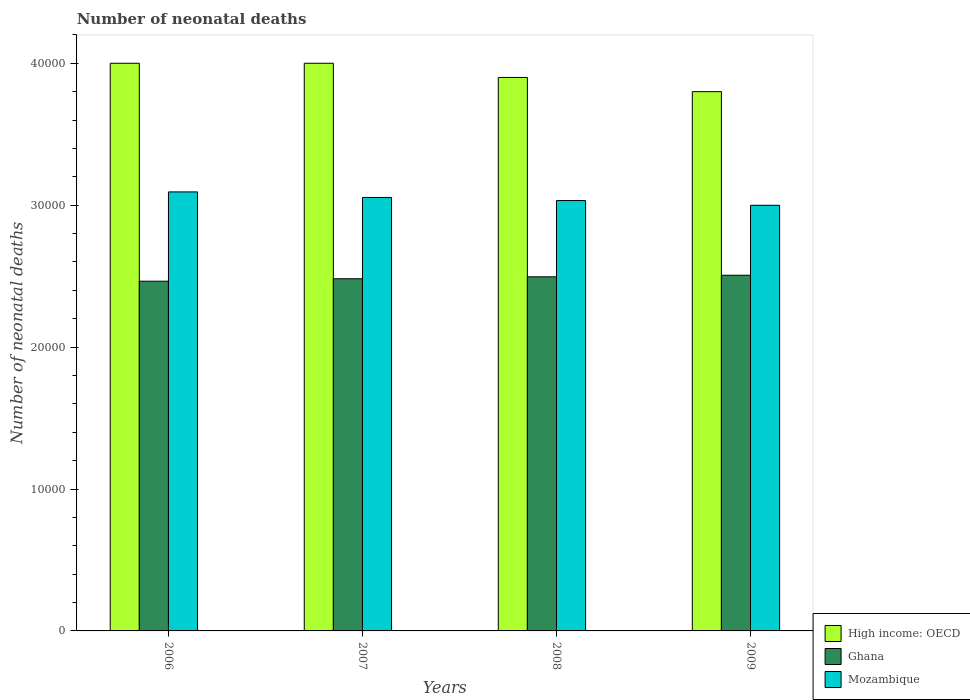How many groups of bars are there?
Provide a short and direct response. 4. Are the number of bars per tick equal to the number of legend labels?
Offer a terse response. Yes. How many bars are there on the 1st tick from the left?
Provide a short and direct response. 3. What is the label of the 2nd group of bars from the left?
Provide a succinct answer. 2007. In how many cases, is the number of bars for a given year not equal to the number of legend labels?
Make the answer very short. 0. What is the number of neonatal deaths in in Ghana in 2009?
Provide a succinct answer. 2.51e+04. Across all years, what is the maximum number of neonatal deaths in in Ghana?
Your answer should be very brief. 2.51e+04. Across all years, what is the minimum number of neonatal deaths in in High income: OECD?
Keep it short and to the point. 3.80e+04. In which year was the number of neonatal deaths in in Ghana maximum?
Keep it short and to the point. 2009. What is the total number of neonatal deaths in in High income: OECD in the graph?
Give a very brief answer. 1.57e+05. What is the difference between the number of neonatal deaths in in High income: OECD in 2007 and that in 2008?
Keep it short and to the point. 1000. What is the difference between the number of neonatal deaths in in High income: OECD in 2007 and the number of neonatal deaths in in Ghana in 2009?
Give a very brief answer. 1.49e+04. What is the average number of neonatal deaths in in Ghana per year?
Ensure brevity in your answer.  2.49e+04. In the year 2006, what is the difference between the number of neonatal deaths in in Ghana and number of neonatal deaths in in Mozambique?
Give a very brief answer. -6292. What is the ratio of the number of neonatal deaths in in High income: OECD in 2007 to that in 2009?
Keep it short and to the point. 1.05. Is the number of neonatal deaths in in High income: OECD in 2007 less than that in 2008?
Provide a succinct answer. No. What is the difference between the highest and the second highest number of neonatal deaths in in Mozambique?
Make the answer very short. 390. What is the difference between the highest and the lowest number of neonatal deaths in in High income: OECD?
Make the answer very short. 2000. What does the 2nd bar from the left in 2007 represents?
Offer a terse response. Ghana. What does the 3rd bar from the right in 2008 represents?
Provide a short and direct response. High income: OECD. Is it the case that in every year, the sum of the number of neonatal deaths in in Mozambique and number of neonatal deaths in in Ghana is greater than the number of neonatal deaths in in High income: OECD?
Provide a short and direct response. Yes. Are all the bars in the graph horizontal?
Your answer should be very brief. No. How many years are there in the graph?
Make the answer very short. 4. What is the difference between two consecutive major ticks on the Y-axis?
Offer a terse response. 10000. Does the graph contain any zero values?
Make the answer very short. No. How many legend labels are there?
Your answer should be very brief. 3. How are the legend labels stacked?
Give a very brief answer. Vertical. What is the title of the graph?
Offer a very short reply. Number of neonatal deaths. Does "Jamaica" appear as one of the legend labels in the graph?
Your response must be concise. No. What is the label or title of the X-axis?
Provide a short and direct response. Years. What is the label or title of the Y-axis?
Ensure brevity in your answer.  Number of neonatal deaths. What is the Number of neonatal deaths of Ghana in 2006?
Ensure brevity in your answer.  2.46e+04. What is the Number of neonatal deaths of Mozambique in 2006?
Provide a short and direct response. 3.09e+04. What is the Number of neonatal deaths of High income: OECD in 2007?
Offer a very short reply. 4.00e+04. What is the Number of neonatal deaths of Ghana in 2007?
Make the answer very short. 2.48e+04. What is the Number of neonatal deaths of Mozambique in 2007?
Your response must be concise. 3.05e+04. What is the Number of neonatal deaths in High income: OECD in 2008?
Your answer should be very brief. 3.90e+04. What is the Number of neonatal deaths of Ghana in 2008?
Your answer should be compact. 2.50e+04. What is the Number of neonatal deaths in Mozambique in 2008?
Provide a short and direct response. 3.03e+04. What is the Number of neonatal deaths of High income: OECD in 2009?
Give a very brief answer. 3.80e+04. What is the Number of neonatal deaths of Ghana in 2009?
Your response must be concise. 2.51e+04. What is the Number of neonatal deaths of Mozambique in 2009?
Keep it short and to the point. 3.00e+04. Across all years, what is the maximum Number of neonatal deaths in High income: OECD?
Keep it short and to the point. 4.00e+04. Across all years, what is the maximum Number of neonatal deaths in Ghana?
Make the answer very short. 2.51e+04. Across all years, what is the maximum Number of neonatal deaths of Mozambique?
Your response must be concise. 3.09e+04. Across all years, what is the minimum Number of neonatal deaths in High income: OECD?
Your response must be concise. 3.80e+04. Across all years, what is the minimum Number of neonatal deaths of Ghana?
Ensure brevity in your answer.  2.46e+04. Across all years, what is the minimum Number of neonatal deaths in Mozambique?
Make the answer very short. 3.00e+04. What is the total Number of neonatal deaths of High income: OECD in the graph?
Make the answer very short. 1.57e+05. What is the total Number of neonatal deaths of Ghana in the graph?
Your response must be concise. 9.95e+04. What is the total Number of neonatal deaths in Mozambique in the graph?
Make the answer very short. 1.22e+05. What is the difference between the Number of neonatal deaths in High income: OECD in 2006 and that in 2007?
Provide a short and direct response. 0. What is the difference between the Number of neonatal deaths in Ghana in 2006 and that in 2007?
Your answer should be very brief. -173. What is the difference between the Number of neonatal deaths of Mozambique in 2006 and that in 2007?
Your response must be concise. 390. What is the difference between the Number of neonatal deaths of Ghana in 2006 and that in 2008?
Make the answer very short. -308. What is the difference between the Number of neonatal deaths of Mozambique in 2006 and that in 2008?
Provide a succinct answer. 608. What is the difference between the Number of neonatal deaths in Ghana in 2006 and that in 2009?
Offer a very short reply. -421. What is the difference between the Number of neonatal deaths in Mozambique in 2006 and that in 2009?
Offer a terse response. 943. What is the difference between the Number of neonatal deaths in High income: OECD in 2007 and that in 2008?
Provide a short and direct response. 1000. What is the difference between the Number of neonatal deaths in Ghana in 2007 and that in 2008?
Keep it short and to the point. -135. What is the difference between the Number of neonatal deaths of Mozambique in 2007 and that in 2008?
Provide a short and direct response. 218. What is the difference between the Number of neonatal deaths in High income: OECD in 2007 and that in 2009?
Your answer should be compact. 2000. What is the difference between the Number of neonatal deaths in Ghana in 2007 and that in 2009?
Make the answer very short. -248. What is the difference between the Number of neonatal deaths in Mozambique in 2007 and that in 2009?
Provide a succinct answer. 553. What is the difference between the Number of neonatal deaths of Ghana in 2008 and that in 2009?
Your answer should be very brief. -113. What is the difference between the Number of neonatal deaths in Mozambique in 2008 and that in 2009?
Provide a succinct answer. 335. What is the difference between the Number of neonatal deaths in High income: OECD in 2006 and the Number of neonatal deaths in Ghana in 2007?
Provide a succinct answer. 1.52e+04. What is the difference between the Number of neonatal deaths in High income: OECD in 2006 and the Number of neonatal deaths in Mozambique in 2007?
Keep it short and to the point. 9456. What is the difference between the Number of neonatal deaths of Ghana in 2006 and the Number of neonatal deaths of Mozambique in 2007?
Offer a terse response. -5902. What is the difference between the Number of neonatal deaths of High income: OECD in 2006 and the Number of neonatal deaths of Ghana in 2008?
Keep it short and to the point. 1.50e+04. What is the difference between the Number of neonatal deaths in High income: OECD in 2006 and the Number of neonatal deaths in Mozambique in 2008?
Your answer should be compact. 9674. What is the difference between the Number of neonatal deaths of Ghana in 2006 and the Number of neonatal deaths of Mozambique in 2008?
Ensure brevity in your answer.  -5684. What is the difference between the Number of neonatal deaths of High income: OECD in 2006 and the Number of neonatal deaths of Ghana in 2009?
Your response must be concise. 1.49e+04. What is the difference between the Number of neonatal deaths in High income: OECD in 2006 and the Number of neonatal deaths in Mozambique in 2009?
Offer a very short reply. 1.00e+04. What is the difference between the Number of neonatal deaths of Ghana in 2006 and the Number of neonatal deaths of Mozambique in 2009?
Make the answer very short. -5349. What is the difference between the Number of neonatal deaths in High income: OECD in 2007 and the Number of neonatal deaths in Ghana in 2008?
Provide a succinct answer. 1.50e+04. What is the difference between the Number of neonatal deaths of High income: OECD in 2007 and the Number of neonatal deaths of Mozambique in 2008?
Your response must be concise. 9674. What is the difference between the Number of neonatal deaths in Ghana in 2007 and the Number of neonatal deaths in Mozambique in 2008?
Provide a succinct answer. -5511. What is the difference between the Number of neonatal deaths of High income: OECD in 2007 and the Number of neonatal deaths of Ghana in 2009?
Ensure brevity in your answer.  1.49e+04. What is the difference between the Number of neonatal deaths in High income: OECD in 2007 and the Number of neonatal deaths in Mozambique in 2009?
Offer a terse response. 1.00e+04. What is the difference between the Number of neonatal deaths in Ghana in 2007 and the Number of neonatal deaths in Mozambique in 2009?
Your answer should be very brief. -5176. What is the difference between the Number of neonatal deaths in High income: OECD in 2008 and the Number of neonatal deaths in Ghana in 2009?
Your answer should be compact. 1.39e+04. What is the difference between the Number of neonatal deaths in High income: OECD in 2008 and the Number of neonatal deaths in Mozambique in 2009?
Ensure brevity in your answer.  9009. What is the difference between the Number of neonatal deaths in Ghana in 2008 and the Number of neonatal deaths in Mozambique in 2009?
Ensure brevity in your answer.  -5041. What is the average Number of neonatal deaths of High income: OECD per year?
Your answer should be compact. 3.92e+04. What is the average Number of neonatal deaths in Ghana per year?
Provide a short and direct response. 2.49e+04. What is the average Number of neonatal deaths in Mozambique per year?
Keep it short and to the point. 3.04e+04. In the year 2006, what is the difference between the Number of neonatal deaths in High income: OECD and Number of neonatal deaths in Ghana?
Make the answer very short. 1.54e+04. In the year 2006, what is the difference between the Number of neonatal deaths of High income: OECD and Number of neonatal deaths of Mozambique?
Offer a very short reply. 9066. In the year 2006, what is the difference between the Number of neonatal deaths in Ghana and Number of neonatal deaths in Mozambique?
Make the answer very short. -6292. In the year 2007, what is the difference between the Number of neonatal deaths of High income: OECD and Number of neonatal deaths of Ghana?
Provide a succinct answer. 1.52e+04. In the year 2007, what is the difference between the Number of neonatal deaths in High income: OECD and Number of neonatal deaths in Mozambique?
Keep it short and to the point. 9456. In the year 2007, what is the difference between the Number of neonatal deaths of Ghana and Number of neonatal deaths of Mozambique?
Keep it short and to the point. -5729. In the year 2008, what is the difference between the Number of neonatal deaths in High income: OECD and Number of neonatal deaths in Ghana?
Ensure brevity in your answer.  1.40e+04. In the year 2008, what is the difference between the Number of neonatal deaths of High income: OECD and Number of neonatal deaths of Mozambique?
Provide a short and direct response. 8674. In the year 2008, what is the difference between the Number of neonatal deaths in Ghana and Number of neonatal deaths in Mozambique?
Your answer should be compact. -5376. In the year 2009, what is the difference between the Number of neonatal deaths of High income: OECD and Number of neonatal deaths of Ghana?
Ensure brevity in your answer.  1.29e+04. In the year 2009, what is the difference between the Number of neonatal deaths of High income: OECD and Number of neonatal deaths of Mozambique?
Offer a very short reply. 8009. In the year 2009, what is the difference between the Number of neonatal deaths in Ghana and Number of neonatal deaths in Mozambique?
Make the answer very short. -4928. What is the ratio of the Number of neonatal deaths of High income: OECD in 2006 to that in 2007?
Your answer should be compact. 1. What is the ratio of the Number of neonatal deaths of Mozambique in 2006 to that in 2007?
Your answer should be very brief. 1.01. What is the ratio of the Number of neonatal deaths in High income: OECD in 2006 to that in 2008?
Ensure brevity in your answer.  1.03. What is the ratio of the Number of neonatal deaths in Ghana in 2006 to that in 2008?
Your answer should be compact. 0.99. What is the ratio of the Number of neonatal deaths of High income: OECD in 2006 to that in 2009?
Offer a terse response. 1.05. What is the ratio of the Number of neonatal deaths in Ghana in 2006 to that in 2009?
Make the answer very short. 0.98. What is the ratio of the Number of neonatal deaths in Mozambique in 2006 to that in 2009?
Your answer should be compact. 1.03. What is the ratio of the Number of neonatal deaths in High income: OECD in 2007 to that in 2008?
Give a very brief answer. 1.03. What is the ratio of the Number of neonatal deaths of Ghana in 2007 to that in 2008?
Provide a short and direct response. 0.99. What is the ratio of the Number of neonatal deaths of Mozambique in 2007 to that in 2008?
Provide a short and direct response. 1.01. What is the ratio of the Number of neonatal deaths in High income: OECD in 2007 to that in 2009?
Provide a succinct answer. 1.05. What is the ratio of the Number of neonatal deaths in Ghana in 2007 to that in 2009?
Keep it short and to the point. 0.99. What is the ratio of the Number of neonatal deaths in Mozambique in 2007 to that in 2009?
Give a very brief answer. 1.02. What is the ratio of the Number of neonatal deaths of High income: OECD in 2008 to that in 2009?
Your answer should be very brief. 1.03. What is the ratio of the Number of neonatal deaths of Mozambique in 2008 to that in 2009?
Provide a succinct answer. 1.01. What is the difference between the highest and the second highest Number of neonatal deaths of High income: OECD?
Your response must be concise. 0. What is the difference between the highest and the second highest Number of neonatal deaths in Ghana?
Make the answer very short. 113. What is the difference between the highest and the second highest Number of neonatal deaths of Mozambique?
Your answer should be very brief. 390. What is the difference between the highest and the lowest Number of neonatal deaths in Ghana?
Provide a short and direct response. 421. What is the difference between the highest and the lowest Number of neonatal deaths in Mozambique?
Keep it short and to the point. 943. 